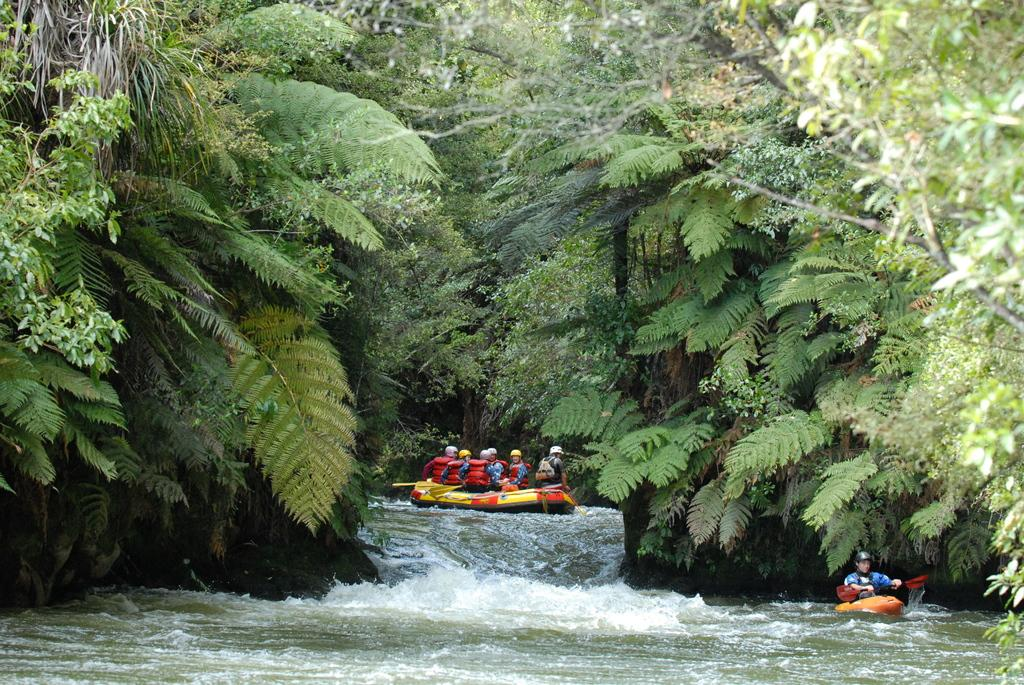What activity are the people in the image engaged in? The people in the image are rafting in the water. What type of natural environment can be seen in the image? Trees and the ground are visible in the image. What type of camera is the grandfather using to take pictures of the rafting scene? There is no grandfather or camera present in the image. 